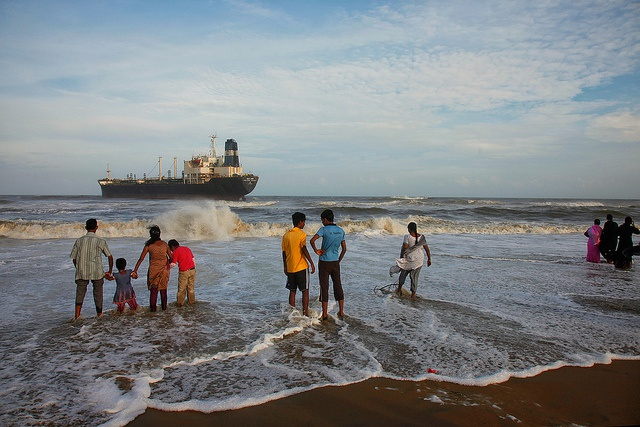Describe the objects in this image and their specific colors. I can see boat in gray, black, and darkgray tones, people in gray, black, maroon, darkgray, and brown tones, people in gray, black, and maroon tones, people in gray, black, blue, maroon, and teal tones, and people in gray, black, darkgray, and maroon tones in this image. 